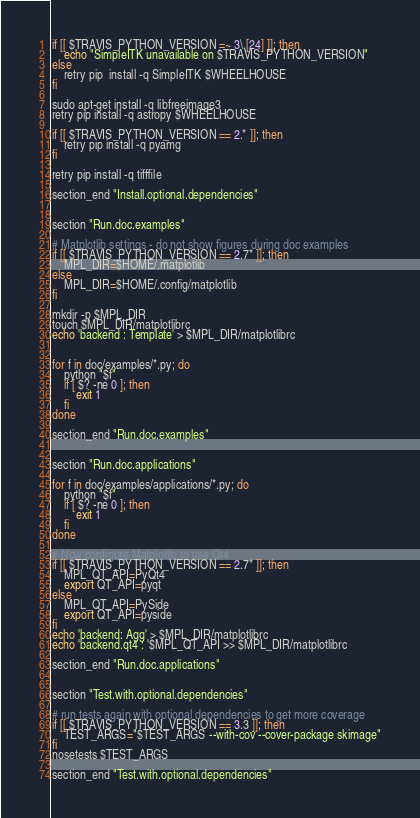Convert code to text. <code><loc_0><loc_0><loc_500><loc_500><_Bash_>if [[ $TRAVIS_PYTHON_VERSION =~ 3\.[24] ]]; then
    echo "SimpleITK unavailable on $TRAVIS_PYTHON_VERSION"
else
    retry pip  install -q SimpleITK $WHEELHOUSE
fi

sudo apt-get install -q libfreeimage3
retry pip install -q astropy $WHEELHOUSE

if [[ $TRAVIS_PYTHON_VERSION == 2.* ]]; then
    retry pip install -q pyamg
fi

retry pip install -q tifffile

section_end "Install.optional.dependencies"


section "Run.doc.examples"

# Matplotlib settings - do not show figures during doc examples
if [[ $TRAVIS_PYTHON_VERSION == 2.7* ]]; then
    MPL_DIR=$HOME/.matplotlib
else
    MPL_DIR=$HOME/.config/matplotlib
fi

mkdir -p $MPL_DIR
touch $MPL_DIR/matplotlibrc
echo 'backend : Template' > $MPL_DIR/matplotlibrc


for f in doc/examples/*.py; do
    python "$f"
    if [ $? -ne 0 ]; then
        exit 1
    fi
done

section_end "Run.doc.examples"


section "Run.doc.applications"

for f in doc/examples/applications/*.py; do
    python "$f"
    if [ $? -ne 0 ]; then
        exit 1
    fi
done

# Now configure Matplotlib to use Qt4
if [[ $TRAVIS_PYTHON_VERSION == 2.7* ]]; then
    MPL_QT_API=PyQt4
    export QT_API=pyqt
else
    MPL_QT_API=PySide
    export QT_API=pyside
fi
echo 'backend: Agg' > $MPL_DIR/matplotlibrc
echo 'backend.qt4 : '$MPL_QT_API >> $MPL_DIR/matplotlibrc

section_end "Run.doc.applications"


section "Test.with.optional.dependencies"

# run tests again with optional dependencies to get more coverage
if [[ $TRAVIS_PYTHON_VERSION == 3.3 ]]; then
    TEST_ARGS="$TEST_ARGS --with-cov --cover-package skimage"
fi
nosetests $TEST_ARGS

section_end "Test.with.optional.dependencies"
</code> 